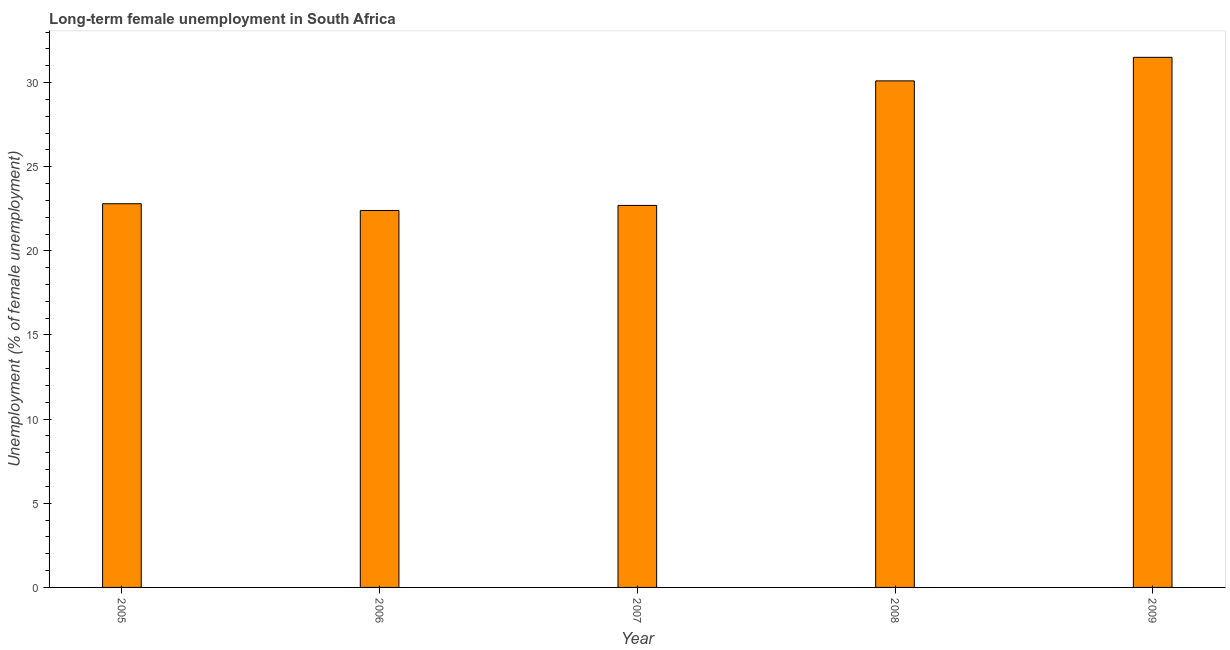Does the graph contain any zero values?
Provide a short and direct response. No. Does the graph contain grids?
Your answer should be compact. No. What is the title of the graph?
Make the answer very short. Long-term female unemployment in South Africa. What is the label or title of the Y-axis?
Offer a very short reply. Unemployment (% of female unemployment). What is the long-term female unemployment in 2009?
Your answer should be very brief. 31.5. Across all years, what is the maximum long-term female unemployment?
Provide a short and direct response. 31.5. Across all years, what is the minimum long-term female unemployment?
Make the answer very short. 22.4. In which year was the long-term female unemployment maximum?
Provide a short and direct response. 2009. What is the sum of the long-term female unemployment?
Give a very brief answer. 129.5. What is the average long-term female unemployment per year?
Ensure brevity in your answer.  25.9. What is the median long-term female unemployment?
Provide a short and direct response. 22.8. Do a majority of the years between 2008 and 2006 (inclusive) have long-term female unemployment greater than 18 %?
Offer a terse response. Yes. What is the ratio of the long-term female unemployment in 2005 to that in 2008?
Give a very brief answer. 0.76. What is the difference between the highest and the second highest long-term female unemployment?
Offer a very short reply. 1.4. Is the sum of the long-term female unemployment in 2005 and 2007 greater than the maximum long-term female unemployment across all years?
Keep it short and to the point. Yes. What is the difference between the highest and the lowest long-term female unemployment?
Your answer should be very brief. 9.1. Are all the bars in the graph horizontal?
Offer a very short reply. No. How many years are there in the graph?
Make the answer very short. 5. What is the difference between two consecutive major ticks on the Y-axis?
Keep it short and to the point. 5. What is the Unemployment (% of female unemployment) of 2005?
Offer a terse response. 22.8. What is the Unemployment (% of female unemployment) of 2006?
Your response must be concise. 22.4. What is the Unemployment (% of female unemployment) of 2007?
Provide a succinct answer. 22.7. What is the Unemployment (% of female unemployment) of 2008?
Offer a terse response. 30.1. What is the Unemployment (% of female unemployment) of 2009?
Your answer should be compact. 31.5. What is the difference between the Unemployment (% of female unemployment) in 2005 and 2006?
Provide a short and direct response. 0.4. What is the difference between the Unemployment (% of female unemployment) in 2005 and 2007?
Provide a short and direct response. 0.1. What is the difference between the Unemployment (% of female unemployment) in 2005 and 2009?
Make the answer very short. -8.7. What is the difference between the Unemployment (% of female unemployment) in 2006 and 2008?
Your response must be concise. -7.7. What is the difference between the Unemployment (% of female unemployment) in 2006 and 2009?
Provide a succinct answer. -9.1. What is the difference between the Unemployment (% of female unemployment) in 2007 and 2008?
Give a very brief answer. -7.4. What is the ratio of the Unemployment (% of female unemployment) in 2005 to that in 2006?
Your response must be concise. 1.02. What is the ratio of the Unemployment (% of female unemployment) in 2005 to that in 2007?
Your response must be concise. 1. What is the ratio of the Unemployment (% of female unemployment) in 2005 to that in 2008?
Provide a short and direct response. 0.76. What is the ratio of the Unemployment (% of female unemployment) in 2005 to that in 2009?
Offer a very short reply. 0.72. What is the ratio of the Unemployment (% of female unemployment) in 2006 to that in 2008?
Give a very brief answer. 0.74. What is the ratio of the Unemployment (% of female unemployment) in 2006 to that in 2009?
Give a very brief answer. 0.71. What is the ratio of the Unemployment (% of female unemployment) in 2007 to that in 2008?
Keep it short and to the point. 0.75. What is the ratio of the Unemployment (% of female unemployment) in 2007 to that in 2009?
Keep it short and to the point. 0.72. What is the ratio of the Unemployment (% of female unemployment) in 2008 to that in 2009?
Your answer should be compact. 0.96. 